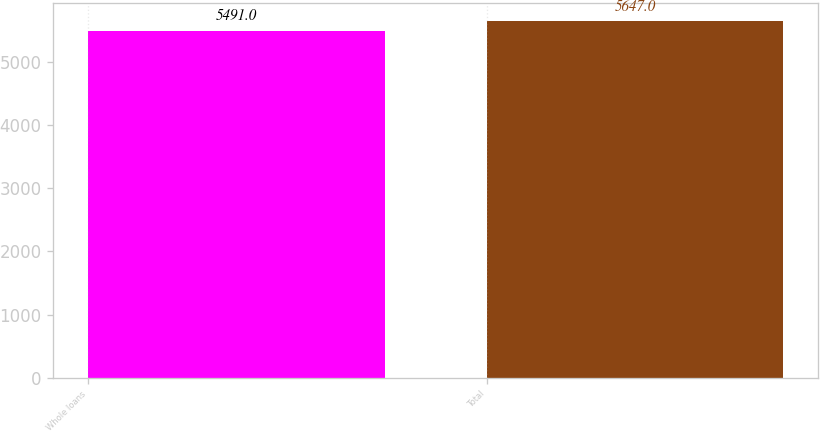<chart> <loc_0><loc_0><loc_500><loc_500><bar_chart><fcel>Whole loans<fcel>Total<nl><fcel>5491<fcel>5647<nl></chart> 